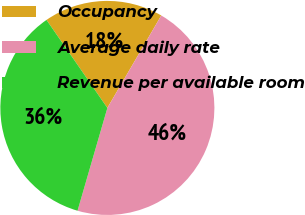Convert chart to OTSL. <chart><loc_0><loc_0><loc_500><loc_500><pie_chart><fcel>Occupancy<fcel>Average daily rate<fcel>Revenue per available room<nl><fcel>18.03%<fcel>46.09%<fcel>35.87%<nl></chart> 